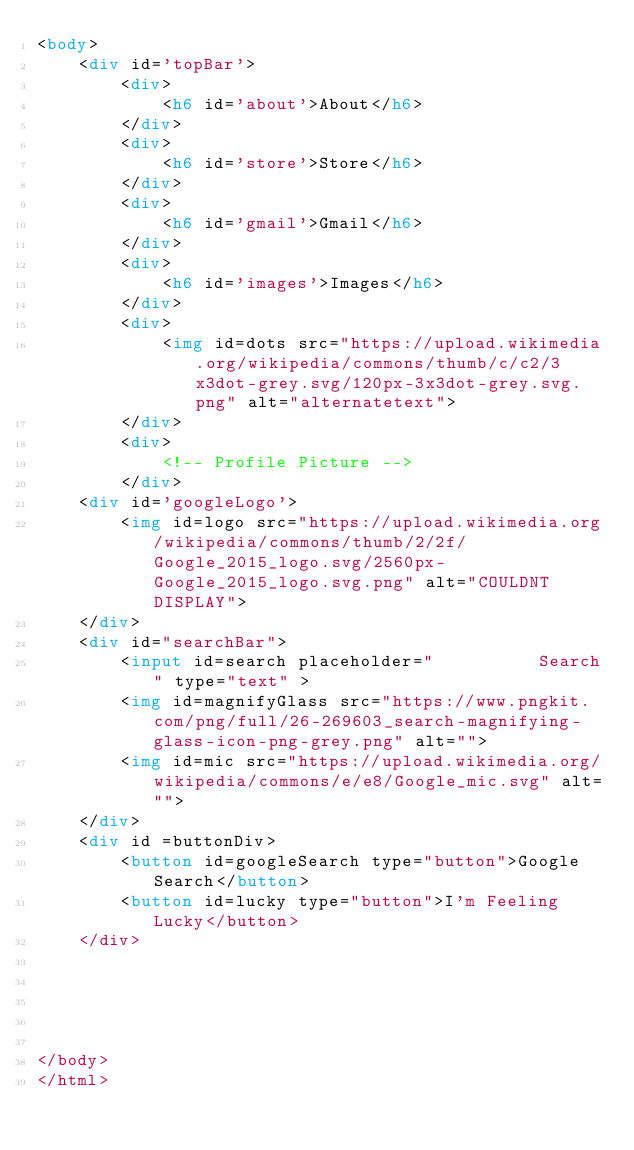Convert code to text. <code><loc_0><loc_0><loc_500><loc_500><_HTML_><body>
    <div id='topBar'>
        <div>
            <h6 id='about'>About</h6> 
        </div>
        <div>
            <h6 id='store'>Store</h6>
        </div>
        <div>
            <h6 id='gmail'>Gmail</h6>
        </div>
        <div>
            <h6 id='images'>Images</h6>
        </div>
        <div>
            <img id=dots src="https://upload.wikimedia.org/wikipedia/commons/thumb/c/c2/3x3dot-grey.svg/120px-3x3dot-grey.svg.png" alt="alternatetext">
        </div>
        <div>
            <!-- Profile Picture -->
        </div>
    <div id='googleLogo'>
        <img id=logo src="https://upload.wikimedia.org/wikipedia/commons/thumb/2/2f/Google_2015_logo.svg/2560px-Google_2015_logo.svg.png" alt="COULDNT DISPLAY">
    </div>
    <div id="searchBar">
        <input id=search placeholder="          Search" type="text" >
        <img id=magnifyGlass src="https://www.pngkit.com/png/full/26-269603_search-magnifying-glass-icon-png-grey.png" alt="">
        <img id=mic src="https://upload.wikimedia.org/wikipedia/commons/e/e8/Google_mic.svg" alt="">
    </div>  
    <div id =buttonDiv>
        <button id=googleSearch type="button">Google Search</button>
        <button id=lucky type="button">I'm Feeling Lucky</button>
    </div>





</body>
</html>

</code> 